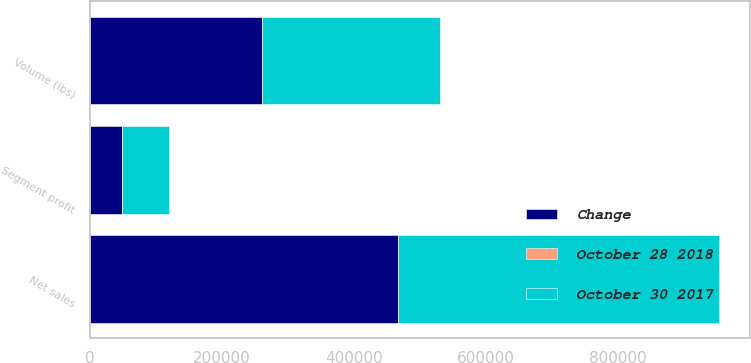Convert chart. <chart><loc_0><loc_0><loc_500><loc_500><stacked_bar_chart><ecel><fcel>Volume (lbs)<fcel>Net sales<fcel>Segment profit<nl><fcel>Change<fcel>260450<fcel>466811<fcel>48829<nl><fcel>October 30 2017<fcel>270175<fcel>484856<fcel>70370<nl><fcel>October 28 2018<fcel>3.6<fcel>3.7<fcel>30.6<nl></chart> 